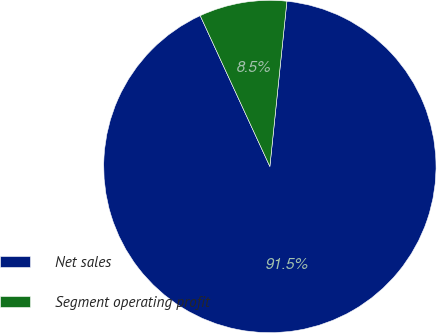Convert chart to OTSL. <chart><loc_0><loc_0><loc_500><loc_500><pie_chart><fcel>Net sales<fcel>Segment operating profit<nl><fcel>91.48%<fcel>8.52%<nl></chart> 